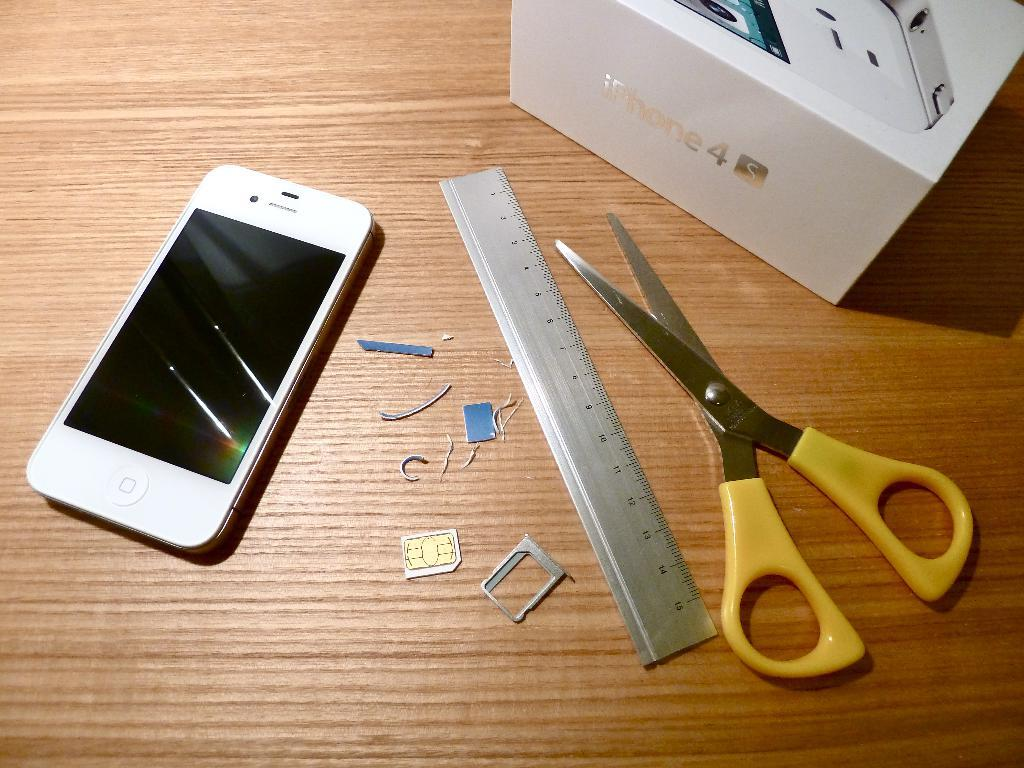What device can be seen in the image? There is a mobile in the image. What tool is present in the image? There are scissors in the image. What object is used for measuring weight in the image? There is a scale in the image. What item is small and rectangular in the image? There is a sim card in the image. What type of container is in the image? There is a box in the image. Can you describe the other unspecified items on the flat surface in the image? Unfortunately, the facts provided do not specify the other items on the flat surface. Where is the lunchroom located in the image? There is no mention of a lunchroom in the image. What type of bat is flying in the image? There are no bats present in the image. 